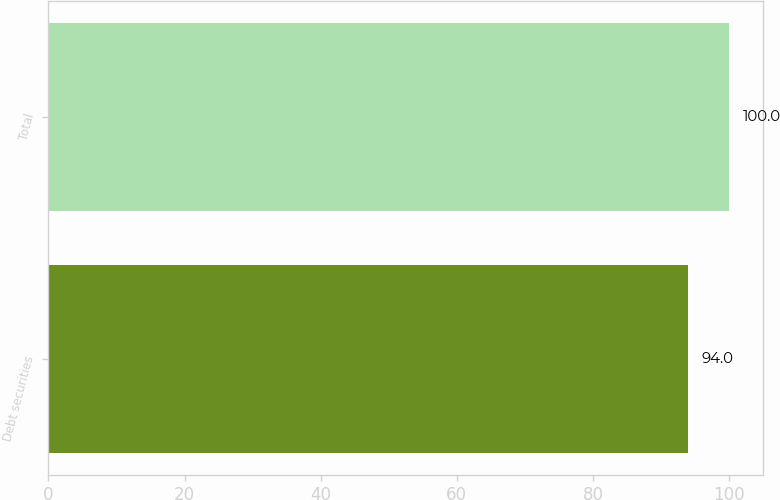Convert chart. <chart><loc_0><loc_0><loc_500><loc_500><bar_chart><fcel>Debt securities<fcel>Total<nl><fcel>94<fcel>100<nl></chart> 